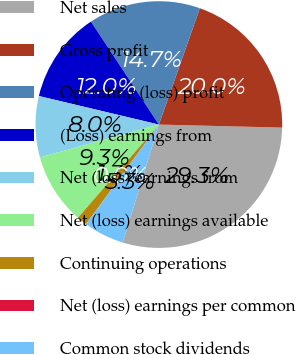Convert chart to OTSL. <chart><loc_0><loc_0><loc_500><loc_500><pie_chart><fcel>Net sales<fcel>Gross profit<fcel>Operating (loss) profit<fcel>(Loss) earnings from<fcel>Net (loss) earnings from<fcel>Net (loss) earnings available<fcel>Continuing operations<fcel>Net (loss) earnings per common<fcel>Common stock dividends<nl><fcel>29.33%<fcel>20.0%<fcel>14.67%<fcel>12.0%<fcel>8.0%<fcel>9.33%<fcel>1.33%<fcel>0.0%<fcel>5.33%<nl></chart> 